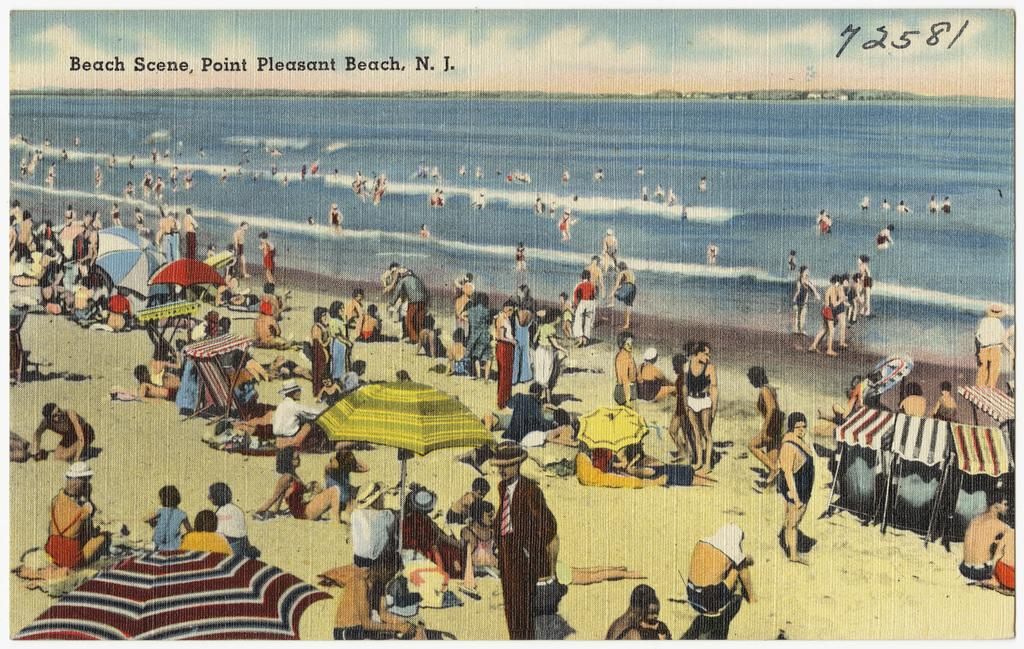What type of visual is the image? The image is a poster. Who or what can be seen in the image? There are people in the image. What objects are present in the image that might provide shelter or protection from the elements? There are umbrellas and a tent in the image. What structures are present in the image that might be used for selling or displaying items? There are stands in the image. What natural elements can be seen in the image? There is water and sand visible in the image. What is written at the top of the image? There is text at the top of the image. What is the income of the person holding the letter in the image? There is no person holding a letter in the image, and therefore no information about their income can be determined. 